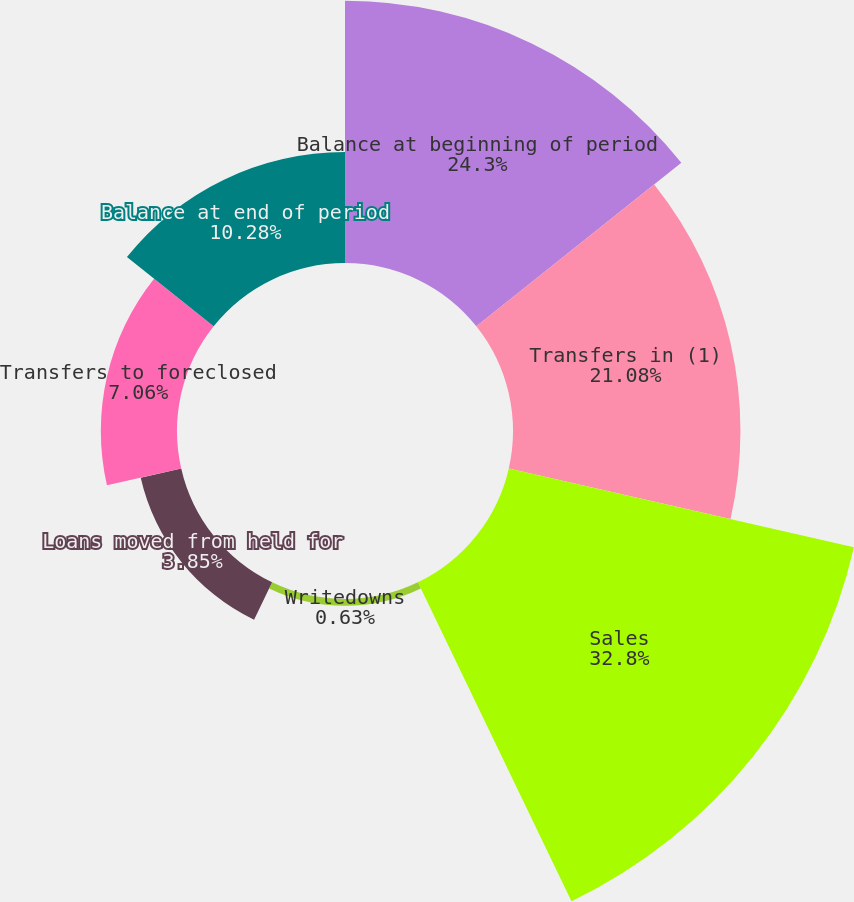Convert chart to OTSL. <chart><loc_0><loc_0><loc_500><loc_500><pie_chart><fcel>Balance at beginning of period<fcel>Transfers in (1)<fcel>Sales<fcel>Writedowns<fcel>Loans moved from held for<fcel>Transfers to foreclosed<fcel>Balance at end of period<nl><fcel>24.3%<fcel>21.08%<fcel>32.81%<fcel>0.63%<fcel>3.85%<fcel>7.06%<fcel>10.28%<nl></chart> 